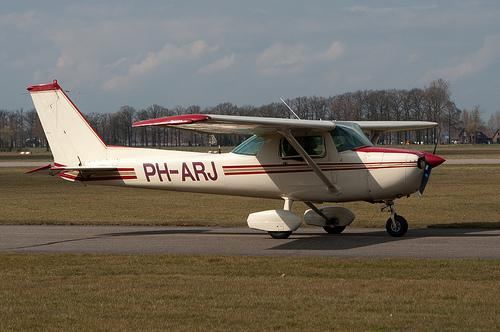Question: what color is the nose of the plane?
Choices:
A. Black.
B. Red.
C. White.
D. Silver.
Answer with the letter. Answer: B Question: what is in the distance?
Choices:
A. Trees.
B. Buildings.
C. Mountains.
D. Gates.
Answer with the letter. Answer: A Question: what letters are on the plane?
Choices:
A. Fljij.
B. Tjeja.
C. Krurl.
D. PH-ARJ.
Answer with the letter. Answer: D Question: how many airplanes are there?
Choices:
A. Two.
B. Four.
C. Three.
D. One.
Answer with the letter. Answer: D Question: where is the airplane?
Choices:
A. Airport.
B. Sky.
C. Runway.
D. Field.
Answer with the letter. Answer: C 